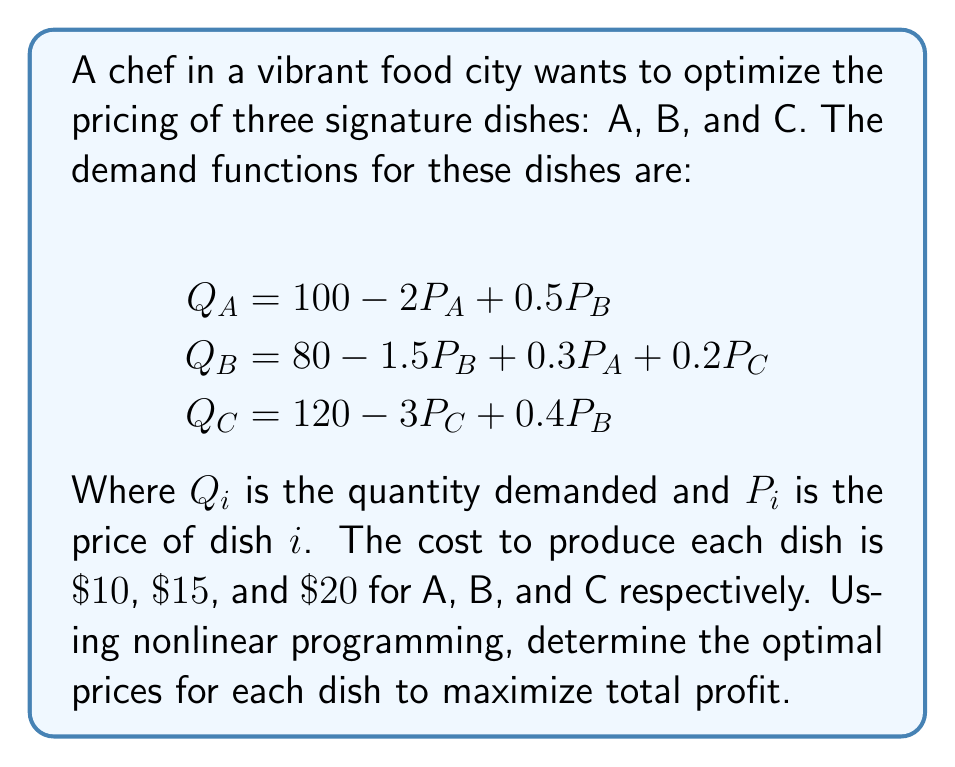Teach me how to tackle this problem. To solve this problem, we'll follow these steps:

1) First, let's define the profit function. The profit for each dish is (Price - Cost) * Quantity. So, the total profit function is:

   $$\Pi = (P_A - 10)Q_A + (P_B - 15)Q_B + (P_C - 20)Q_C$$

2) Substitute the demand functions into the profit function:

   $$\Pi = (P_A - 10)(100 - 2P_A + 0.5P_B) + (P_B - 15)(80 - 1.5P_B + 0.3P_A + 0.2P_C) + (P_C - 20)(120 - 3P_C + 0.4P_B)$$

3) Expand this expression:

   $$\Pi = -2P_A^2 + 120P_A + 0.5P_AP_B - 1000 + 0.3P_AP_B - 1.5P_B^2 + 95P_B + 0.2P_BP_C - 1200 - 3P_C^2 + 180P_C + 0.4P_BP_C - 2400$$

4) To find the maximum profit, we need to find where the partial derivatives with respect to each price are zero:

   $$\frac{\partial \Pi}{\partial P_A} = -4P_A + 120 + 0.5P_B + 0.3P_B = 0$$
   $$\frac{\partial \Pi}{\partial P_B} = 0.5P_A + 0.3P_A - 3P_B + 95 + 0.2P_C + 0.4P_C = 0$$
   $$\frac{\partial \Pi}{\partial P_C} = 0.2P_B + 0.4P_B - 6P_C + 180 = 0$$

5) Simplify these equations:

   $$-4P_A + 0.8P_B + 120 = 0$$
   $$0.8P_A - 3P_B + 0.6P_C + 95 = 0$$
   $$0.6P_B - 6P_C + 180 = 0$$

6) Solve this system of equations. This can be done using matrix methods or substitution. After solving:

   $$P_A \approx 41.67$$
   $$P_B \approx 43.33$$
   $$P_C \approx 40.00$$

These are the optimal prices that maximize profit.
Answer: $P_A \approx \$41.67$, $P_B \approx \$43.33$, $P_C \approx \$40.00$ 